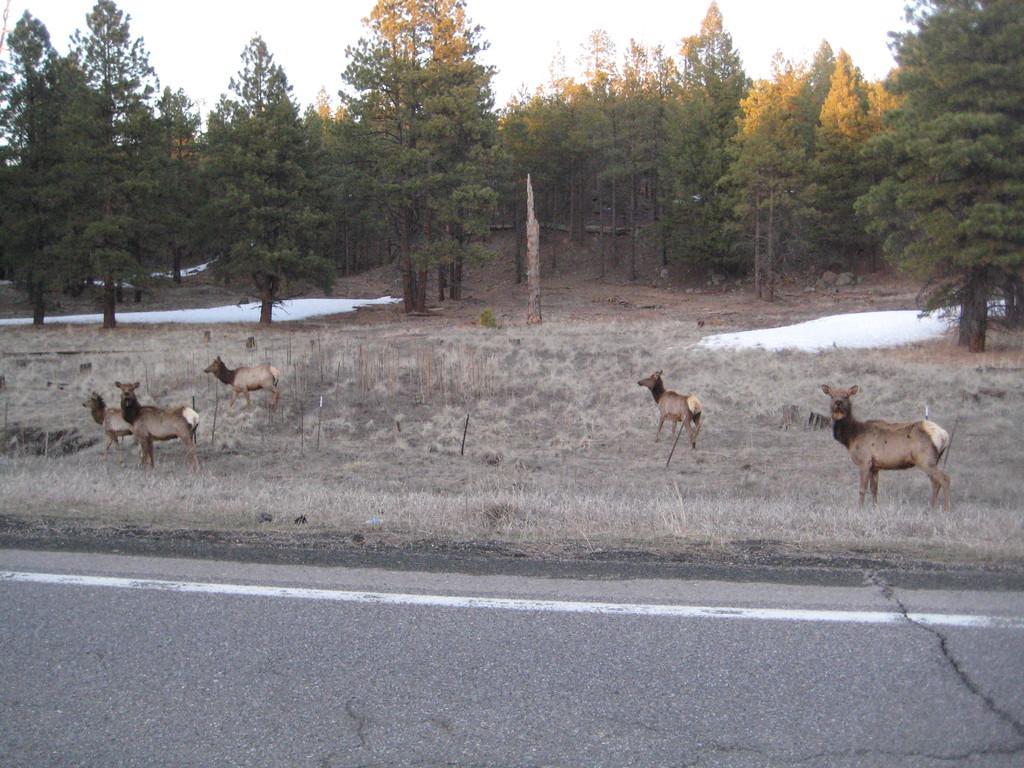Describe this image in one or two sentences. In this picture we can see few years beside to the road, in the background we can find few trees. 